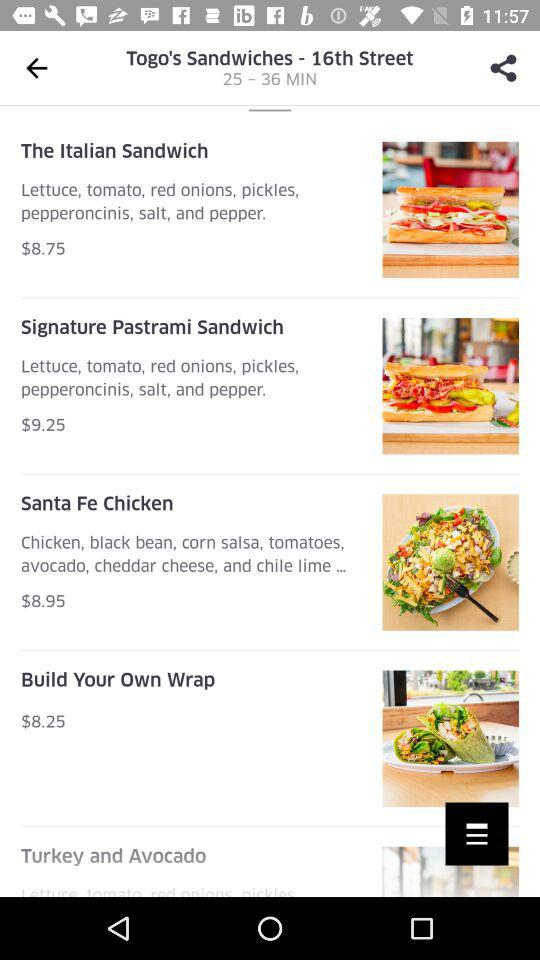What is the cost of a "Santa Fe Chicken"? The cost of a "Santa Fe Chicken" is $8.95. 